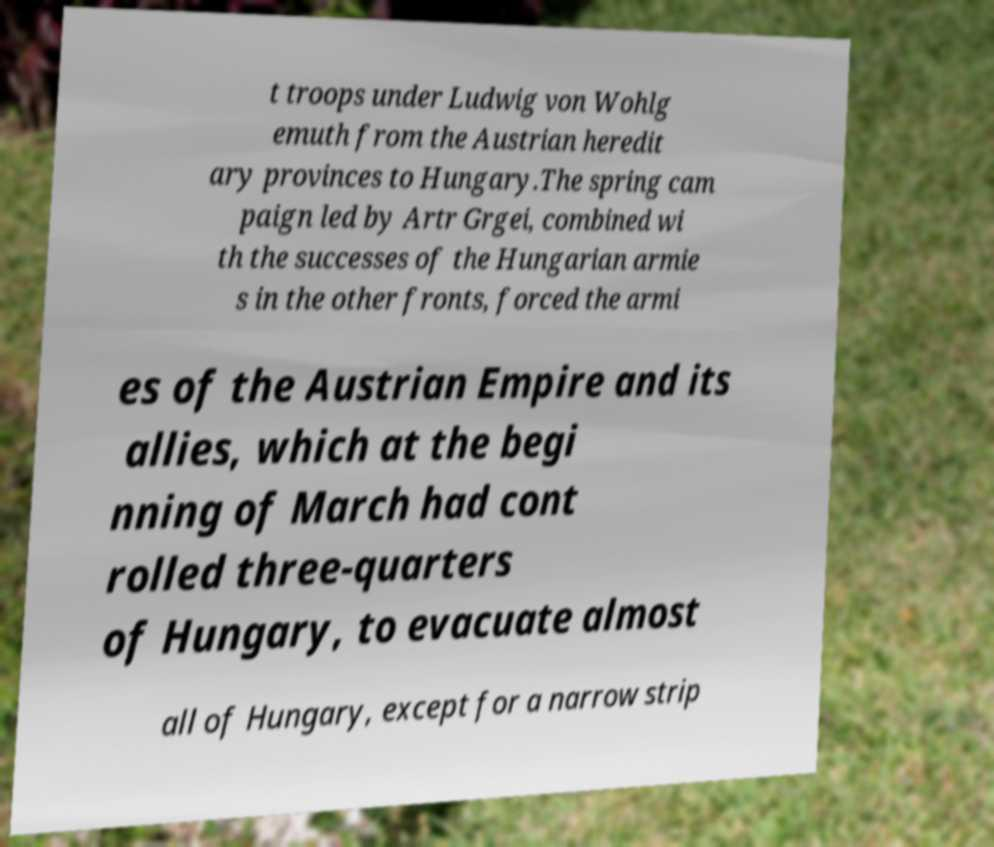Please read and relay the text visible in this image. What does it say? t troops under Ludwig von Wohlg emuth from the Austrian heredit ary provinces to Hungary.The spring cam paign led by Artr Grgei, combined wi th the successes of the Hungarian armie s in the other fronts, forced the armi es of the Austrian Empire and its allies, which at the begi nning of March had cont rolled three-quarters of Hungary, to evacuate almost all of Hungary, except for a narrow strip 